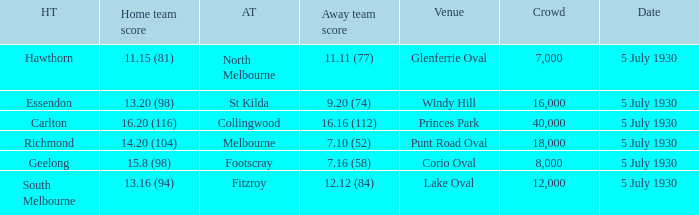What day does the team play at punt road oval? 5 July 1930. 